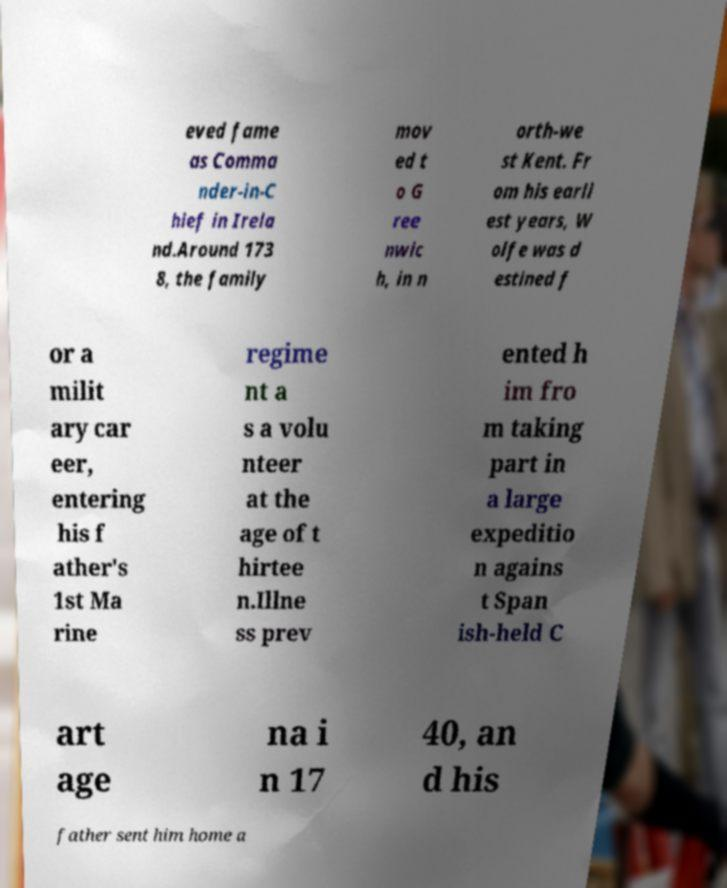Please identify and transcribe the text found in this image. eved fame as Comma nder-in-C hief in Irela nd.Around 173 8, the family mov ed t o G ree nwic h, in n orth-we st Kent. Fr om his earli est years, W olfe was d estined f or a milit ary car eer, entering his f ather's 1st Ma rine regime nt a s a volu nteer at the age of t hirtee n.Illne ss prev ented h im fro m taking part in a large expeditio n agains t Span ish-held C art age na i n 17 40, an d his father sent him home a 